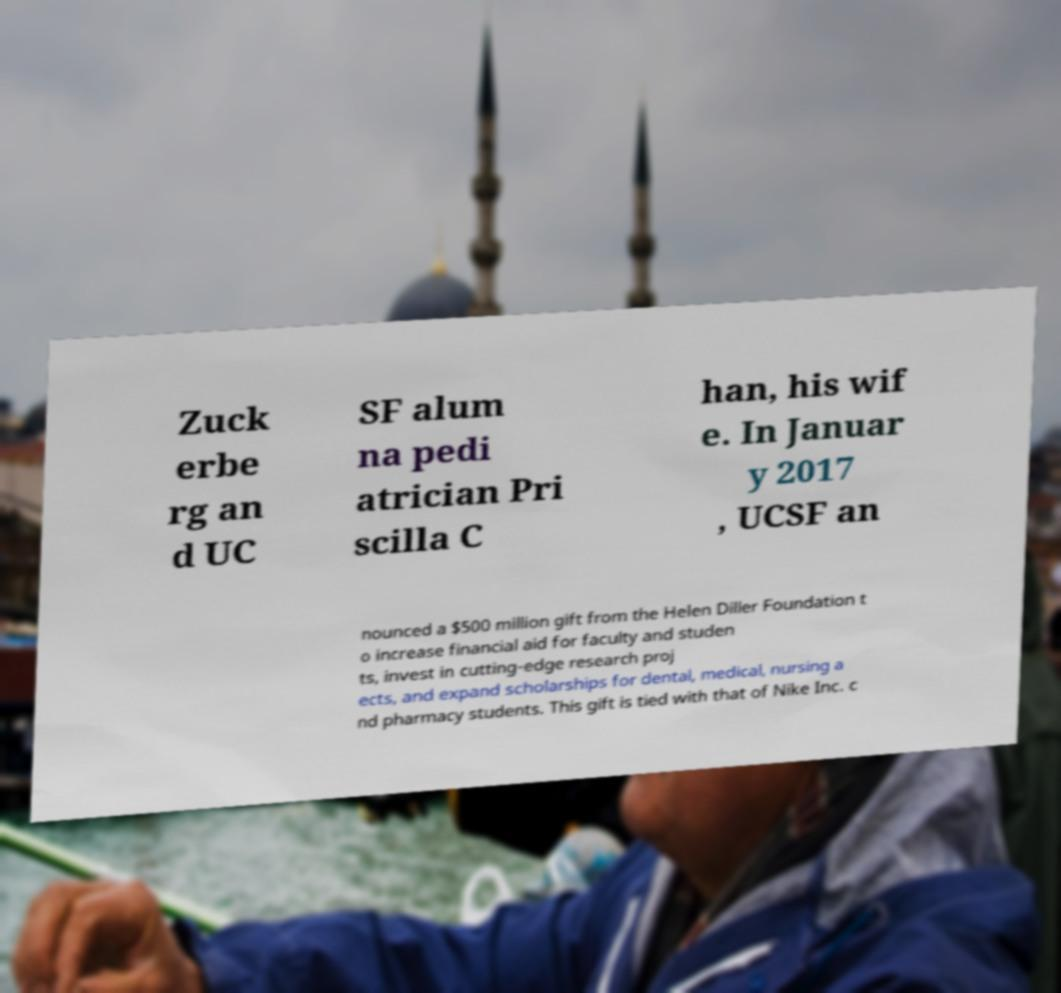I need the written content from this picture converted into text. Can you do that? Zuck erbe rg an d UC SF alum na pedi atrician Pri scilla C han, his wif e. In Januar y 2017 , UCSF an nounced a $500 million gift from the Helen Diller Foundation t o increase financial aid for faculty and studen ts, invest in cutting-edge research proj ects, and expand scholarships for dental, medical, nursing a nd pharmacy students. This gift is tied with that of Nike Inc. c 